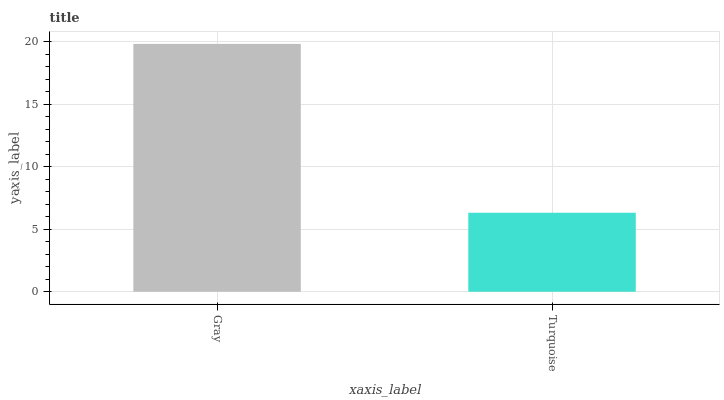Is Turquoise the maximum?
Answer yes or no. No. Is Gray greater than Turquoise?
Answer yes or no. Yes. Is Turquoise less than Gray?
Answer yes or no. Yes. Is Turquoise greater than Gray?
Answer yes or no. No. Is Gray less than Turquoise?
Answer yes or no. No. Is Gray the high median?
Answer yes or no. Yes. Is Turquoise the low median?
Answer yes or no. Yes. Is Turquoise the high median?
Answer yes or no. No. Is Gray the low median?
Answer yes or no. No. 